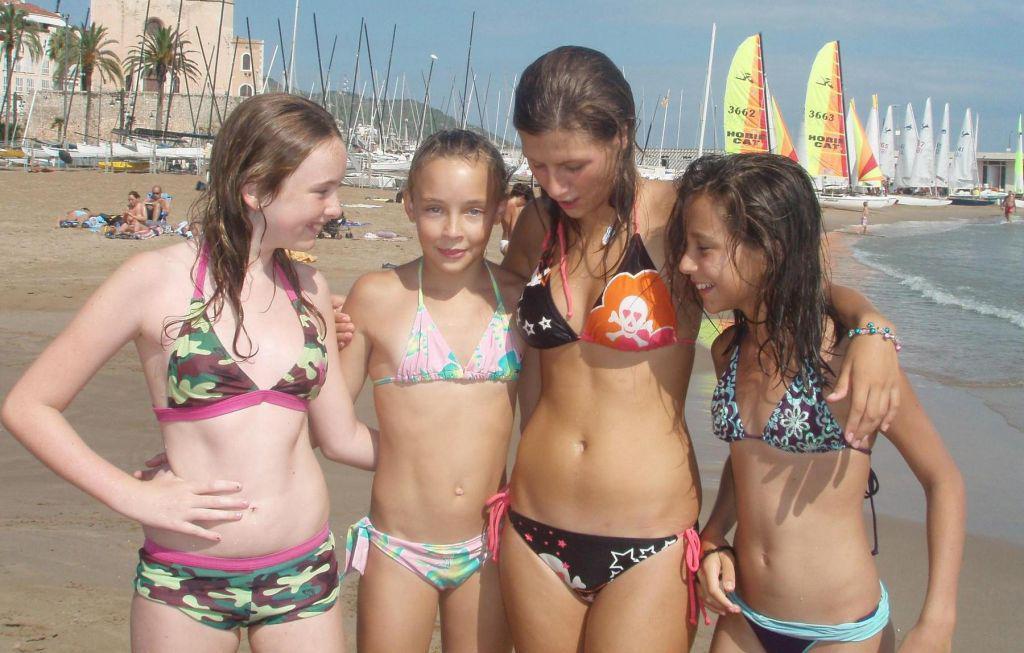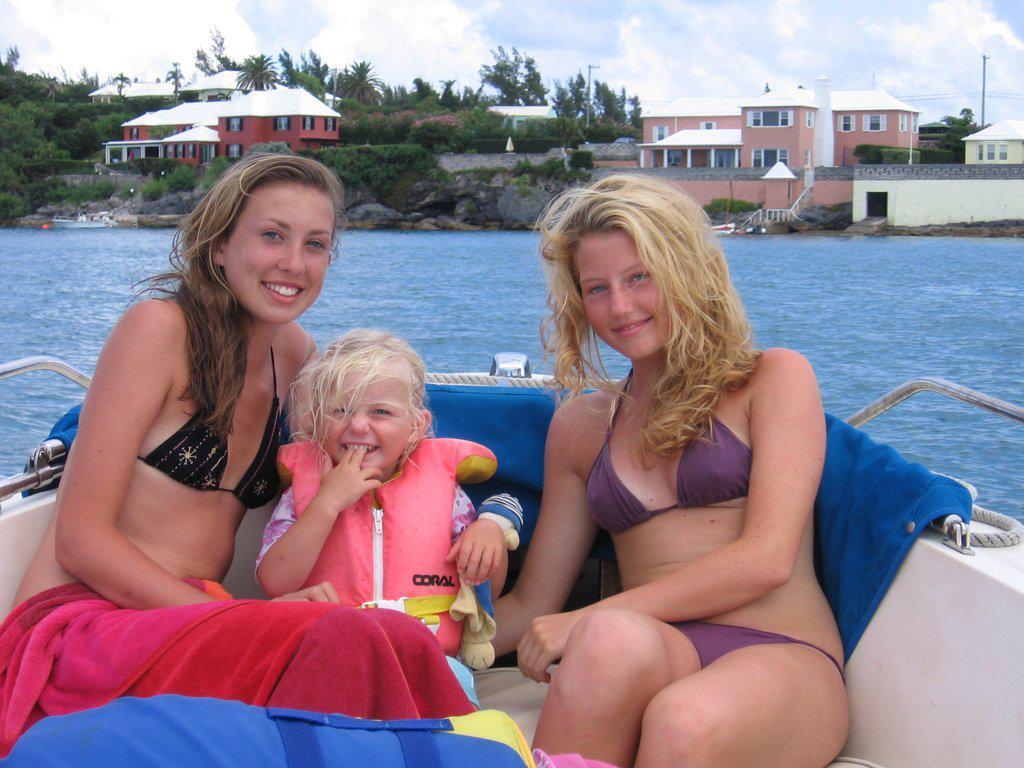The first image is the image on the left, the second image is the image on the right. Evaluate the accuracy of this statement regarding the images: "There are four girls wearing swimsuits at the beach in one of the images.". Is it true? Answer yes or no. Yes. The first image is the image on the left, the second image is the image on the right. Assess this claim about the two images: "There are seven girls.". Correct or not? Answer yes or no. Yes. 